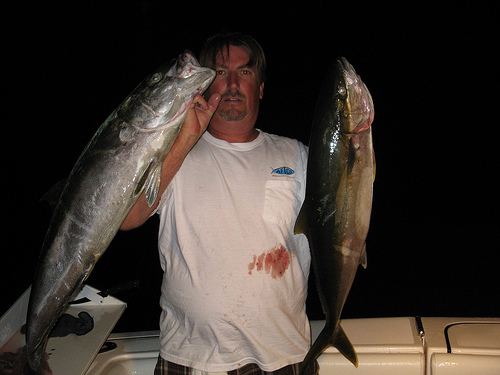<image>
Can you confirm if the man is behind the fish? Yes. From this viewpoint, the man is positioned behind the fish, with the fish partially or fully occluding the man. 